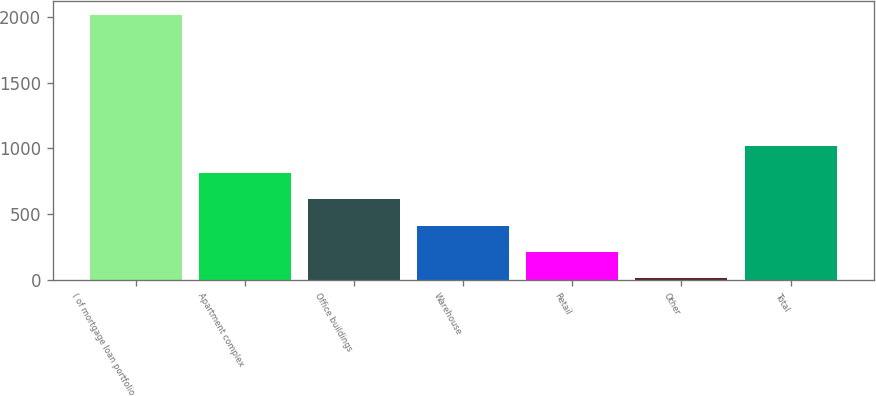Convert chart. <chart><loc_0><loc_0><loc_500><loc_500><bar_chart><fcel>( of mortgage loan portfolio<fcel>Apartment complex<fcel>Office buildings<fcel>Warehouse<fcel>Retail<fcel>Other<fcel>Total<nl><fcel>2018<fcel>813.74<fcel>613.03<fcel>412.32<fcel>211.61<fcel>10.9<fcel>1014.45<nl></chart> 